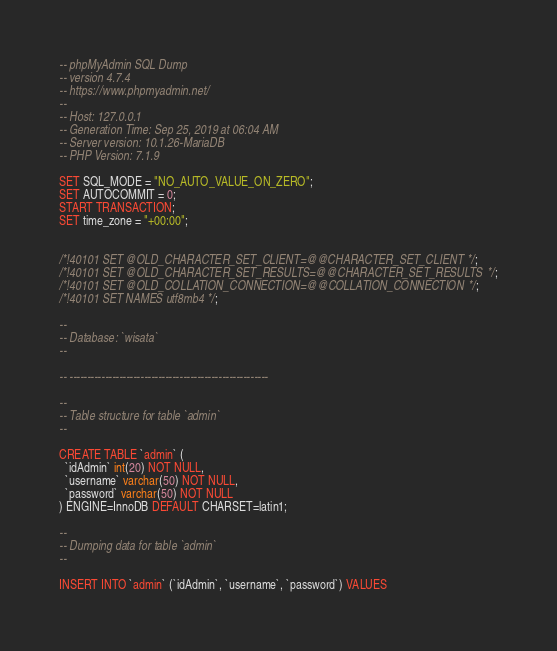Convert code to text. <code><loc_0><loc_0><loc_500><loc_500><_SQL_>-- phpMyAdmin SQL Dump
-- version 4.7.4
-- https://www.phpmyadmin.net/
--
-- Host: 127.0.0.1
-- Generation Time: Sep 25, 2019 at 06:04 AM
-- Server version: 10.1.26-MariaDB
-- PHP Version: 7.1.9

SET SQL_MODE = "NO_AUTO_VALUE_ON_ZERO";
SET AUTOCOMMIT = 0;
START TRANSACTION;
SET time_zone = "+00:00";


/*!40101 SET @OLD_CHARACTER_SET_CLIENT=@@CHARACTER_SET_CLIENT */;
/*!40101 SET @OLD_CHARACTER_SET_RESULTS=@@CHARACTER_SET_RESULTS */;
/*!40101 SET @OLD_COLLATION_CONNECTION=@@COLLATION_CONNECTION */;
/*!40101 SET NAMES utf8mb4 */;

--
-- Database: `wisata`
--

-- --------------------------------------------------------

--
-- Table structure for table `admin`
--

CREATE TABLE `admin` (
  `idAdmin` int(20) NOT NULL,
  `username` varchar(50) NOT NULL,
  `password` varchar(50) NOT NULL
) ENGINE=InnoDB DEFAULT CHARSET=latin1;

--
-- Dumping data for table `admin`
--

INSERT INTO `admin` (`idAdmin`, `username`, `password`) VALUES</code> 